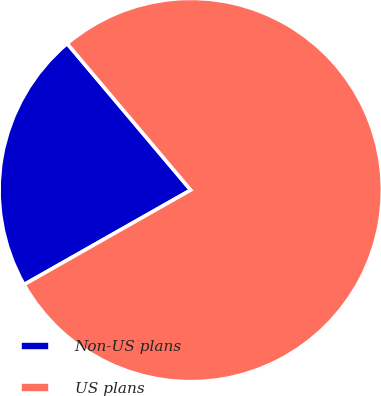Convert chart. <chart><loc_0><loc_0><loc_500><loc_500><pie_chart><fcel>Non-US plans<fcel>US plans<nl><fcel>22.06%<fcel>77.94%<nl></chart> 